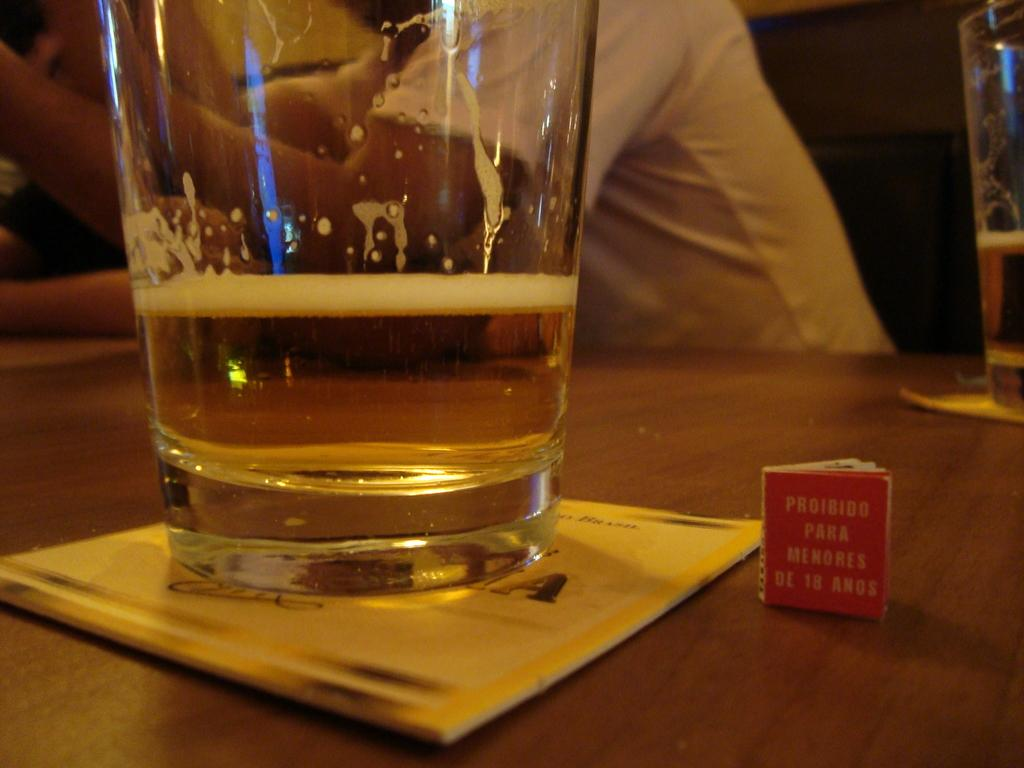<image>
Relay a brief, clear account of the picture shown. almost empty glass of beer next to tiny book proibido para menores 